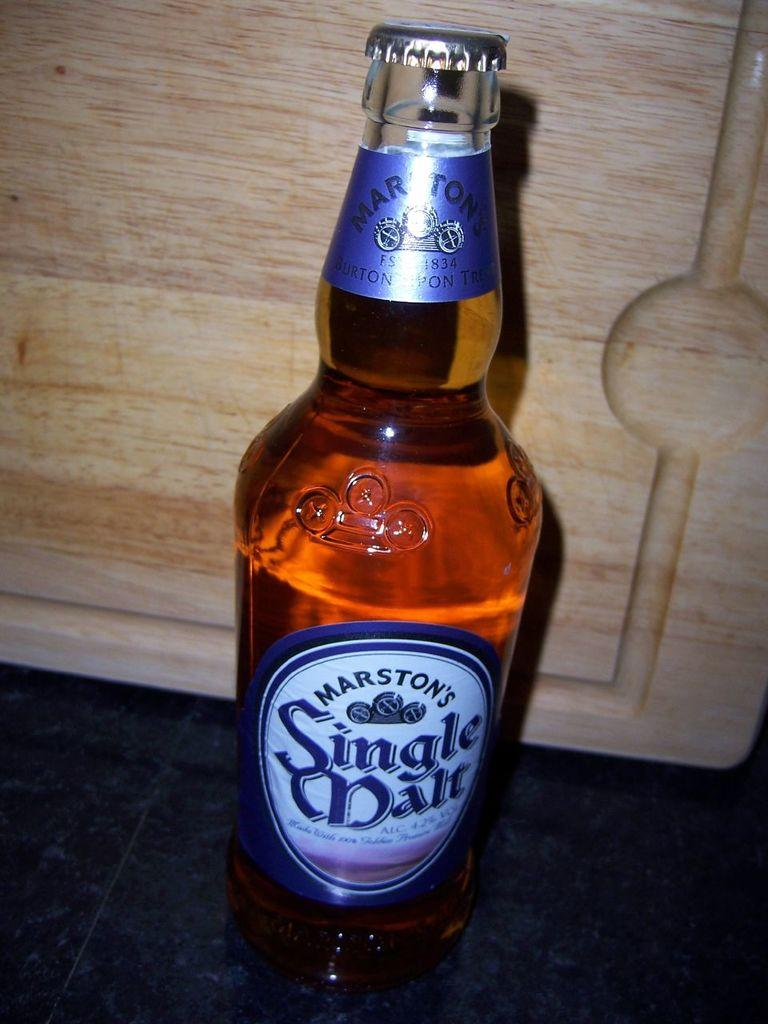<image>
Describe the image concisely. A bottle of Marston's Single malt is sitting by itself. 